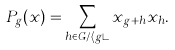Convert formula to latex. <formula><loc_0><loc_0><loc_500><loc_500>P _ { g } ( x ) = \sum _ { h \in G / \langle g \rangle } x _ { g + h } x _ { h } .</formula> 